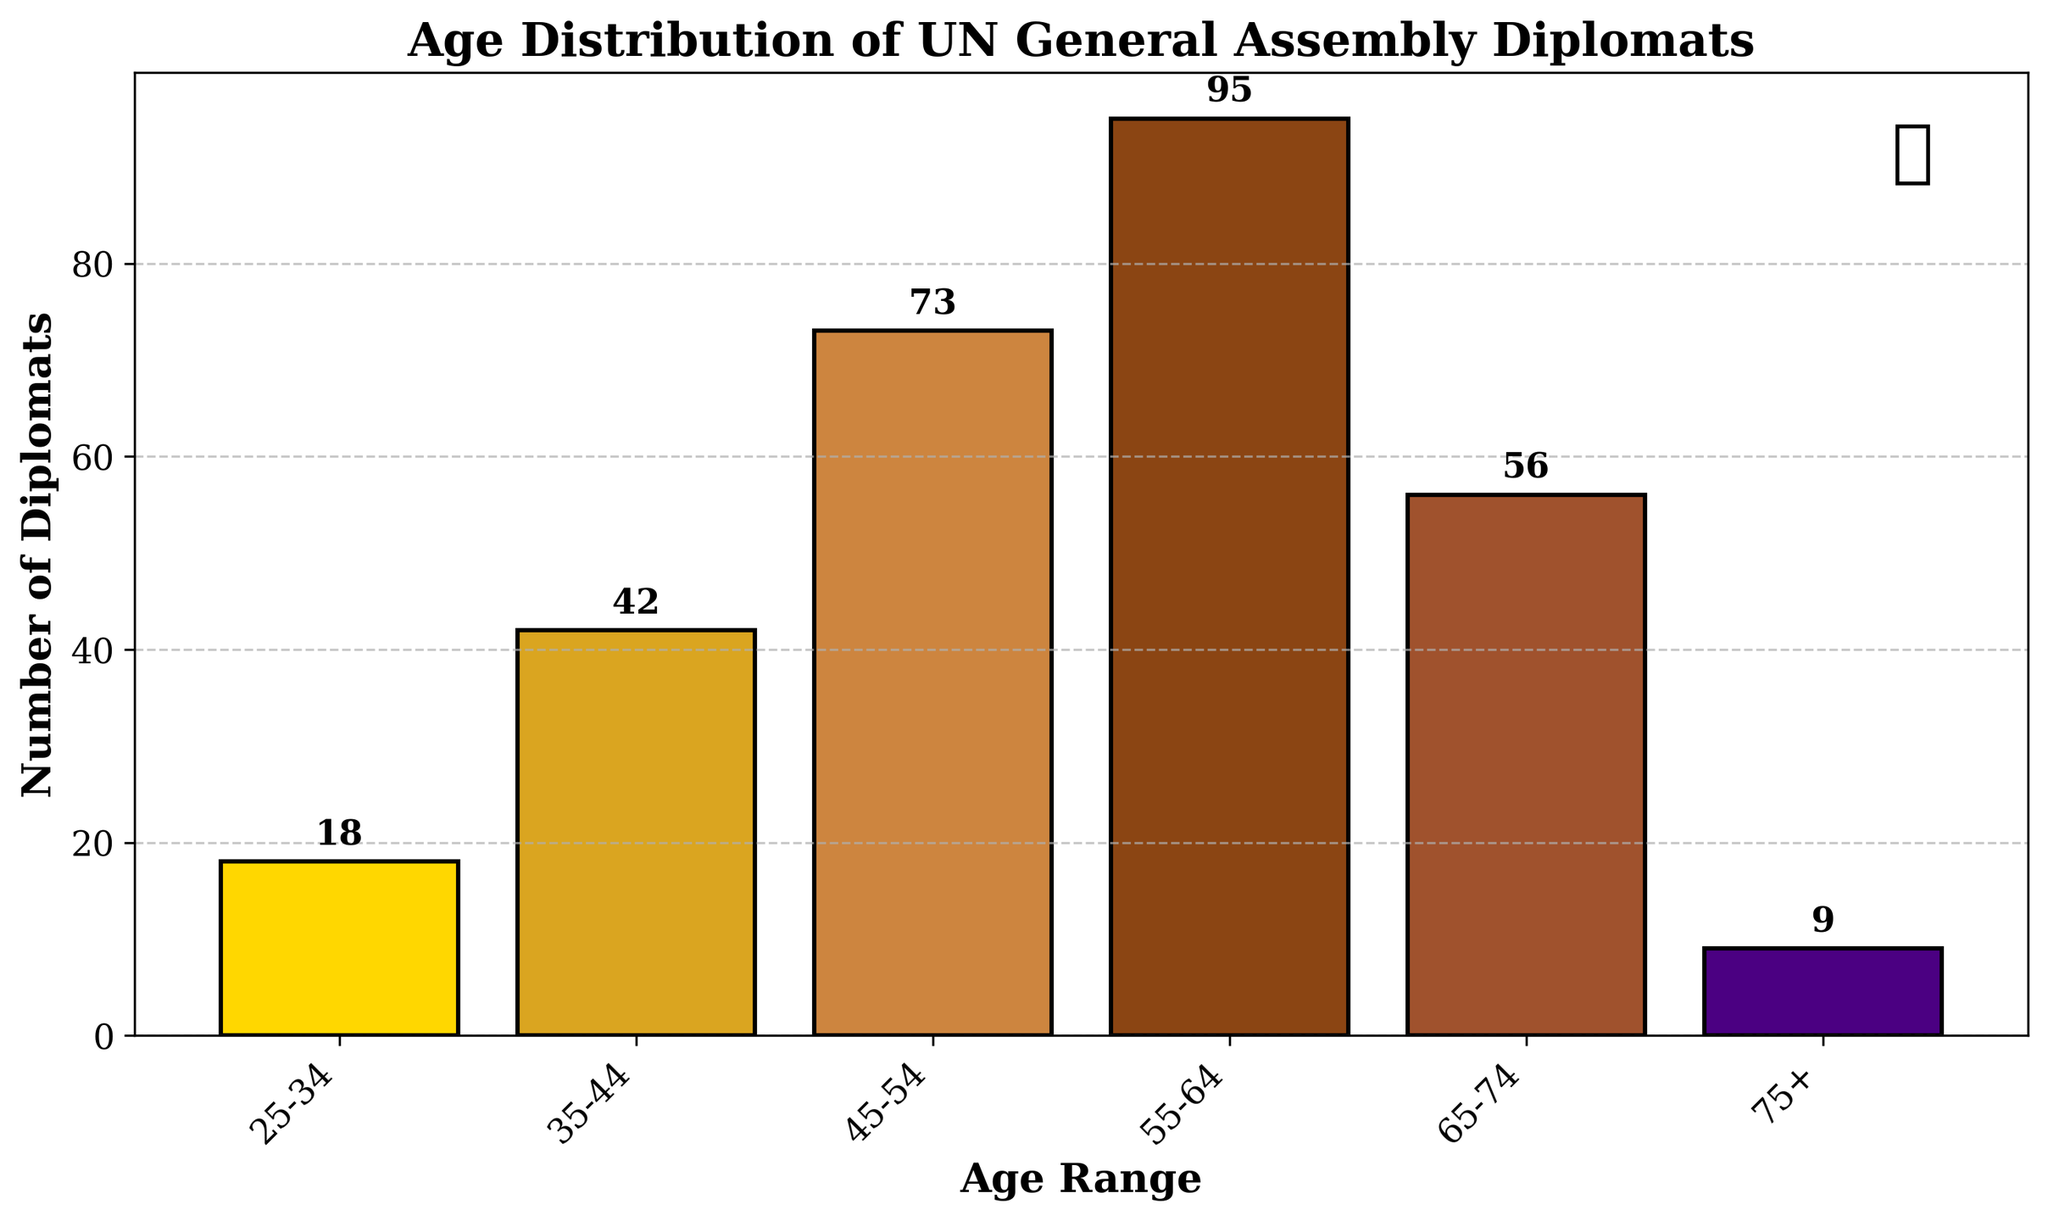What is the title of the figure? The title of the figure is usually placed at the top and it summarizes the content displayed in the chart. In this case, the title is "Age Distribution of UN General Assembly Diplomats" which indicates the purpose of the histogram.
Answer: Age Distribution of UN General Assembly Diplomats Which age range has the highest number of diplomats? To find the age range with the highest number of diplomats, we need to look for the tallest bar in the histogram. The tallest bar corresponds to the age range 55-64 with 95 diplomats.
Answer: 55-64 How many diplomats are aged 75 or older? To determine the number of diplomats aged 75 or older, we find the height of the last bar in the histogram labeled "75+". The height is 9, indicating there are 9 diplomats in this age range.
Answer: 9 What is the total number of diplomats represented in the histogram? To find the total number of diplomats, we sum the counts across all age ranges: 18 (25-34) + 42 (35-44) + 73 (45-54) + 95 (55-64) + 56 (65-74) + 9 (75+). Adding them gives us the total number.
Answer: 293 How many more diplomats are in the 55-64 age range compared to the 25-34 age range? To find the difference, we subtract the number of diplomats in the 25-34 age range (18) from the number in the 55-64 age range (95). The calculation is 95 - 18 = 77.
Answer: 77 Which age ranges have fewer than 20 diplomats? We examine the height of each bar to see which ones have a value less than 20. The 25-34 age range has 18 diplomats, and the 75+ age range has 9 diplomats. Both are fewer than 20.
Answer: 25-34, 75+ What is the average number of diplomats across all age ranges? To find the average, we sum the total number of diplomats (293) and divide by the number of age ranges (6). The calculation is 293 / 6 ≈ 48.83.
Answer: Approximately 48.83 Which two age ranges have the closest number of diplomats? To determine the closest numbers, we compare the diplomat counts for each pair of adjacent bars. The 35-44 age range has 42 diplomats and the 25-34 age range has 18 diplomats. By comparing adjacent pairs, we find that 65-74 (56 diplomats) and 45-54 (73 diplomats) have a difference of 17, which is the smallest.
Answer: 65-74 and 45-54 What patterns can be observed in the age distribution of the diplomats? Observing the histogram, we see that the number of diplomats increases from the 25-34 age range, peaking at the 55-64 range, and then decreases in the older age ranges. This pattern might indicate a tendency for diplomats to reach their peak diplomatic career in their mid-50s to mid-60s.
Answer: Number of diplomats peaks at 55-64 and decreases thereafter Is the distribution of diplomats skewed towards older or younger age ranges? By examining the histogram, we see more bars with higher values towards the older age ranges (e.g., 45-64) suggesting a positively skewed distribution towards older diplomats.
Answer: Towards older age ranges 